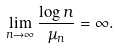<formula> <loc_0><loc_0><loc_500><loc_500>\lim _ { n \rightarrow \infty } \frac { \log n } { \mu _ { n } } = \infty .</formula> 